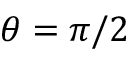Convert formula to latex. <formula><loc_0><loc_0><loc_500><loc_500>\theta = \pi / 2</formula> 